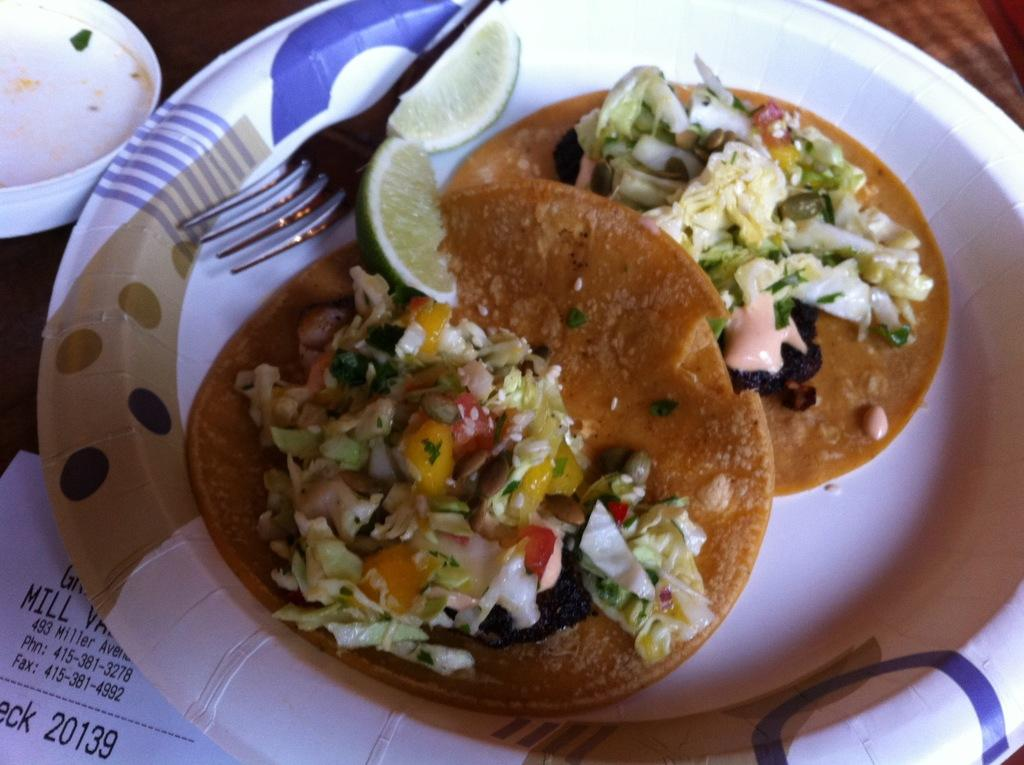What is on the table in the image? There is a plate of food items on the table. What utensil can be seen in the image? There is a fork visible in the image. What type of paper is present in the image? There is a bill paper in the image. What object is on the left side of the image? There is a white color box on the left side of the image. Can you see any fangs on the food items in the image? There are no fangs present on the food items in the image. Is there a scarecrow visible in the image? There is no scarecrow present in the image. 